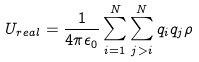<formula> <loc_0><loc_0><loc_500><loc_500>U _ { r e a l } = \frac { 1 } { 4 \pi \epsilon _ { 0 } } \sum _ { i = 1 } ^ { N } \sum _ { j > i } ^ { N } q _ { i } q _ { j } \rho</formula> 